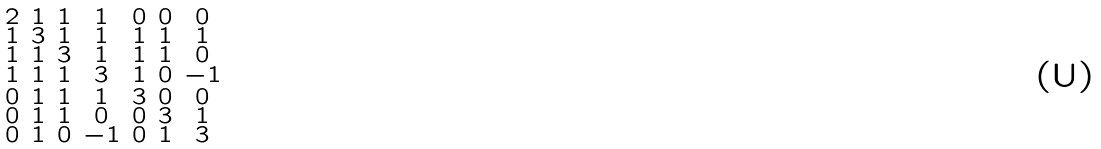Convert formula to latex. <formula><loc_0><loc_0><loc_500><loc_500>\begin{smallmatrix} 2 & 1 & 1 & 1 & 0 & 0 & 0 \\ 1 & 3 & 1 & 1 & 1 & 1 & 1 \\ 1 & 1 & 3 & 1 & 1 & 1 & 0 \\ 1 & 1 & 1 & 3 & 1 & 0 & - 1 \\ 0 & 1 & 1 & 1 & 3 & 0 & 0 \\ 0 & 1 & 1 & 0 & 0 & 3 & 1 \\ 0 & 1 & 0 & - 1 & 0 & 1 & 3 \end{smallmatrix}</formula> 